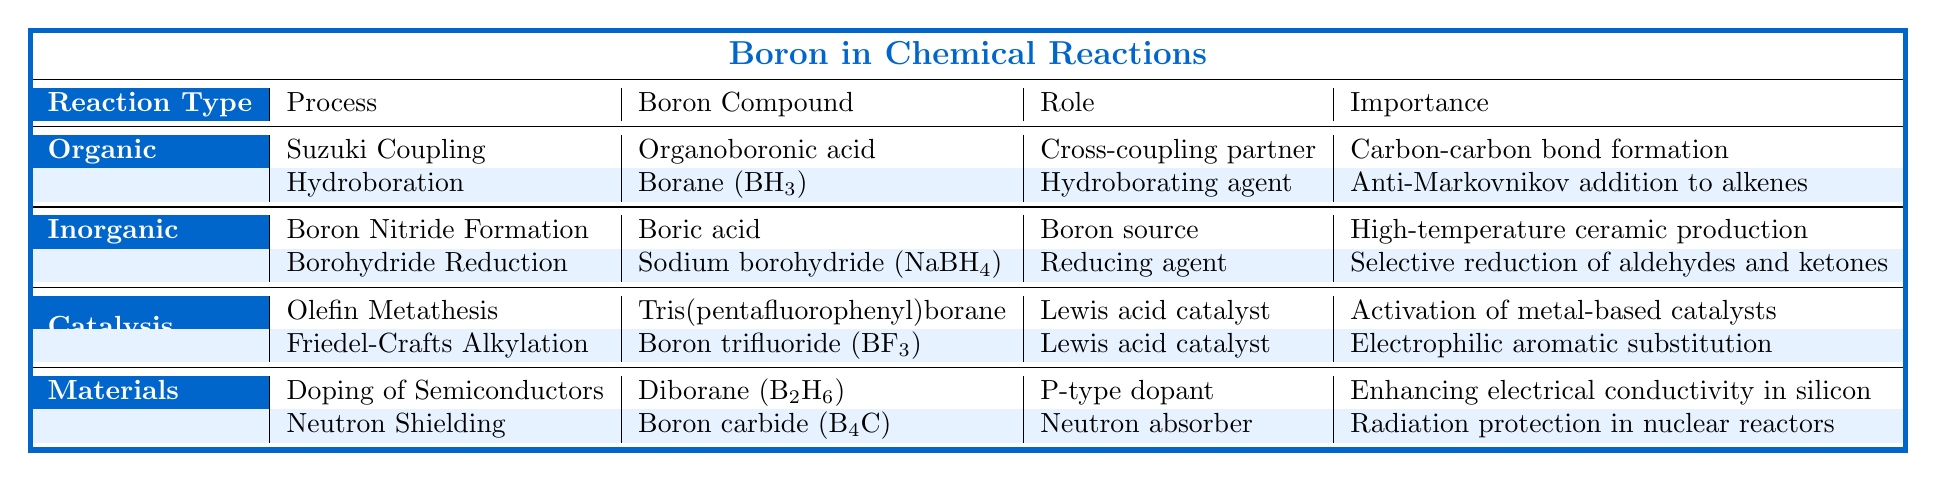What is the role of Boron in the Suzuki Coupling process? In the table, under Organic Synthesis, the Suzuki Coupling process lists "Organoboronic acid" as the Boron compound, and its role is described as a "Cross-coupling partner."
Answer: Cross-coupling partner Which boron compound is used as a reducing agent in Inorganic Synthesis? The table shows that under Inorganic Synthesis in the Borohydride Reduction process, "Sodium borohydride (NaBH4)" is identified as the boron compound and its role is that of a reducing agent.
Answer: Sodium borohydride (NaBH4) Is Boron trifluoride (BF3) used in any catalysis processes? According to the table, Boron trifluoride (BF3) appears in the Catalysis section specifically in the Friedel-Crafts Alkylation process, confirming it is indeed used in catalysis.
Answer: Yes List all the processes where boron is mentioned as a Lewis acid catalyst. The table displays two processes under the Catalysis section: Olefin Metathesis with "Tris(pentafluorophenyl)borane" and Friedel-Crafts Alkylation with "Boron trifluoride (BF3)," both of which indicate that boron serves as a Lewis acid catalyst.
Answer: Olefin Metathesis, Friedel-Crafts Alkylation What is the significance of Diborane (B2H6) in Materials Science? In the table, Diborane (B2H6) is listed under the Doping of Semiconductors process in Materials Science, where its importance is stated as "Enhancing electrical conductivity in silicon."
Answer: Enhancing electrical conductivity in silicon How many different types of reactions involve boron compounds as catalytic agents? The table indicates there are two types of reactions involving boron compounds as catalytic agents: Organic Synthesis and Catalysis, specifically mentioning two processes under Catalysis. Since both Organic Synthesis and Catalysis have processes listed, I sum the counts: 2 (from Catalysis) + 1 (from Organic Synthesis) = 3.
Answer: 3 Which reaction type includes the process of Boron Nitride Formation? The table categorizes Boron Nitride Formation under Inorganic Synthesis, clearly marking its association with this reaction type.
Answer: Inorganic Synthesis Does the table indicate any boron compound involved in neutron shielding? Yes, the table mentions "Boron carbide (B4C)" under the Materials Science section, specifically in the Neutron Shielding process, indicating its role in radiation protection.
Answer: Yes Identify the process in Organic Synthesis that facilitates the formation of carbon-carbon bonds. According to the table, the Suzuki Coupling process is identified under Organic Synthesis, and it specifically notes the importance of "Carbon-carbon bond formation."
Answer: Suzuki Coupling Which boron compound serves as a P-type dopant? The table points out that "Diborane (B2H6)" under the Doping of Semiconductors process is the boron compound acting as a P-type dopant.
Answer: Diborane (B2H6) In which process role does boron facilitate selective reduction? Under Inorganic Synthesis, the process of Borohydride Reduction features Sodium borohydride (NaBH4) as a reducing agent indicated to facilitate "Selective reduction of aldehydes and ketones."
Answer: Borohydride Reduction 